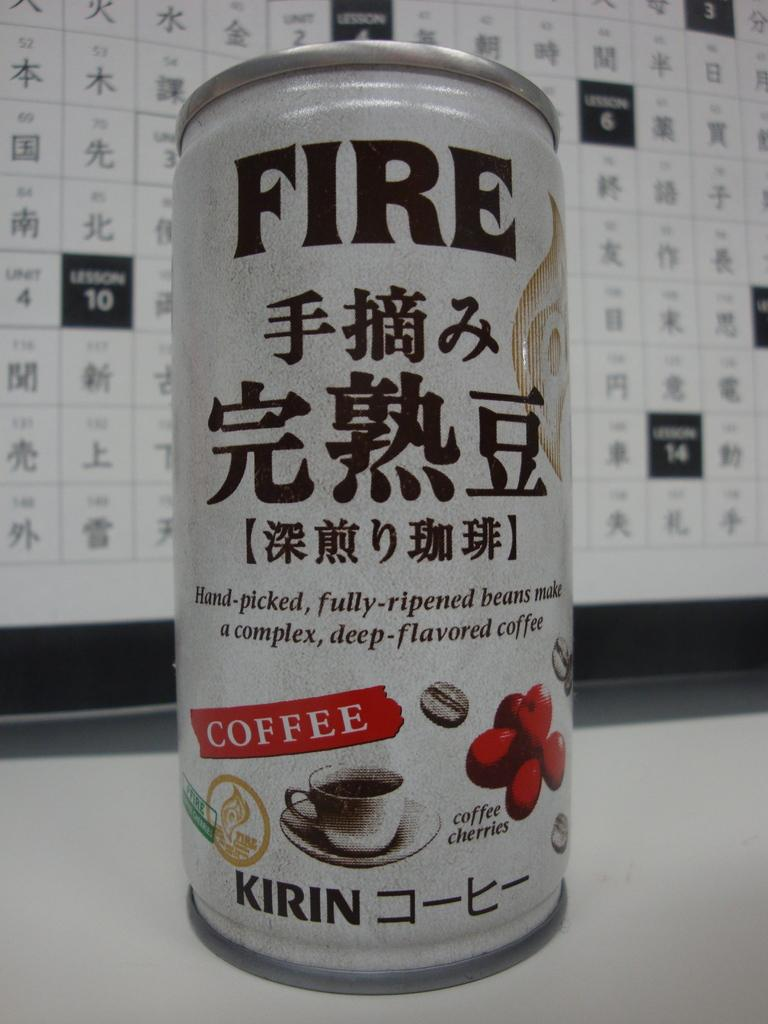<image>
Render a clear and concise summary of the photo. A white can has the word fire on the top. 